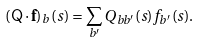<formula> <loc_0><loc_0><loc_500><loc_500>\left ( { \mathsf Q } \cdot { \mathbf f } \right ) _ { b } ( s ) = \sum _ { b ^ { \prime } } Q _ { b b ^ { \prime } } ( s ) f _ { b ^ { \prime } } ( s ) .</formula> 